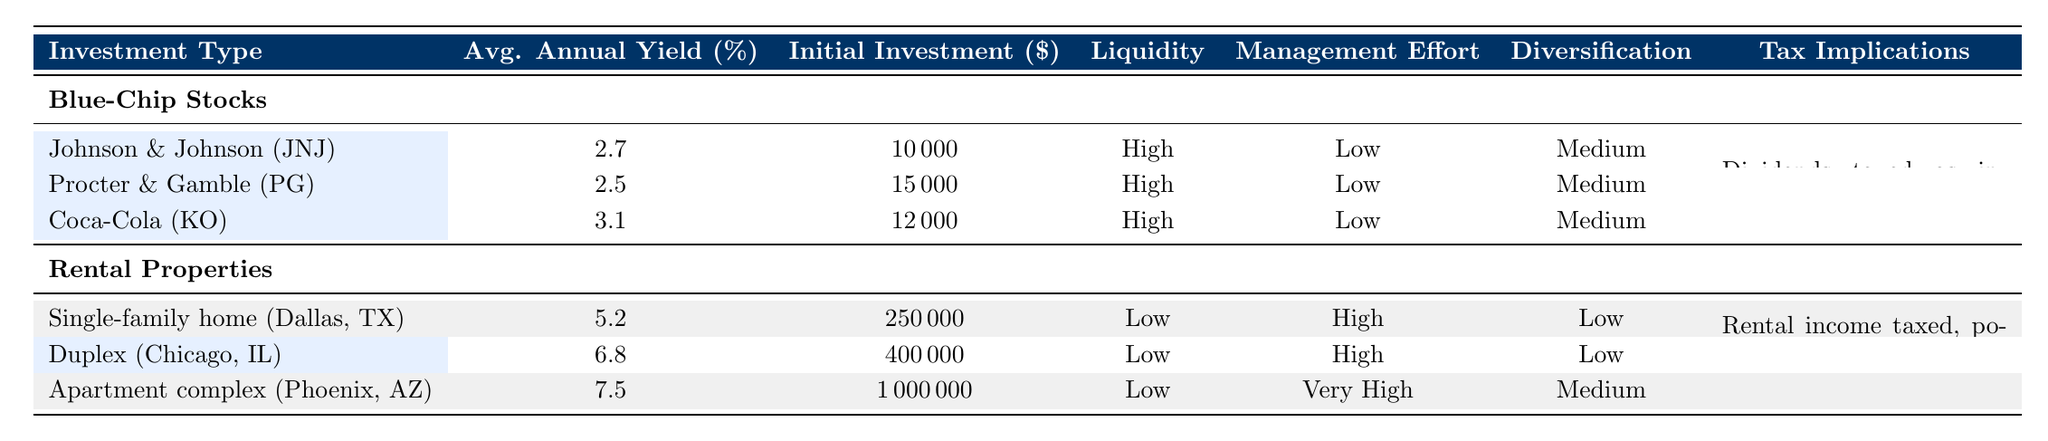What is the average annual yield for Coca-Cola (KO)? Looking at the "Avg. Annual Yield (%)" column for Coca-Cola (KO), it shows a yield of 3.1%. Therefore, the average annual yield for Coca-Cola is 3.1%.
Answer: 3.1% What is the initial investment required for the duplex in Chicago, IL? The "Initial Investment Required ($)" column for the duplex in Chicago shows that the required amount is 400,000 dollars.
Answer: 400,000 Are the tax implications for blue-chip stocks and rental properties the same? The tax implications for blue-chip stocks are "Dividends taxed as income," while for rental properties, it states "Rental income taxed, potential for depreciation deductions." Since these are different, the answer is no.
Answer: No What is the difference in average annual yield between the apartment complex in Phoenix, AZ and Johnson & Johnson (JNJ)? The average annual yield for the apartment complex is 7.5%, and for Johnson & Johnson, it is 2.7%. The difference is calculated as 7.5% - 2.7% = 4.8%.
Answer: 4.8% Which investment type has the highest initial investment required? Reviewing the "Initial Investment Required ($)" column, the apartment complex in Phoenix, AZ requires 1,000,000 dollars, which is higher than any other property or stock listed.
Answer: Apartment complex in Phoenix, AZ Do blue-chip stocks generally have higher liquidity compared to rental properties? Blue-chip stocks have "High" liquidity as indicated in the table, while rental properties have "Low" liquidity. This shows that blue-chip stocks have higher liquidity than rental properties.
Answer: Yes What is the average initial investment required for the blue-chip stocks listed? The initial investments for the blue-chip stocks are 10,000 (JNJ), 15,000 (PG), and 12,000 (KO). The average is calculated as (10,000 + 15,000 + 12,000) / 3 = 12,333.33 dollars.
Answer: 12,333.33 Is the management effort required for a single-family home higher than that for Coca-Cola (KO)? The management effort for the single-family home is "High," while for Coca-Cola it is "Low." Therefore, the management effort for the single-family home is indeed higher.
Answer: Yes How many investment types listed have a yield above 5%? Looking at the "Avg. Annual Yield (%)" column, the yields above 5% are from the duplex (6.8%) and the apartment complex (7.5%). So there are 2 investment types above 5%.
Answer: 2 